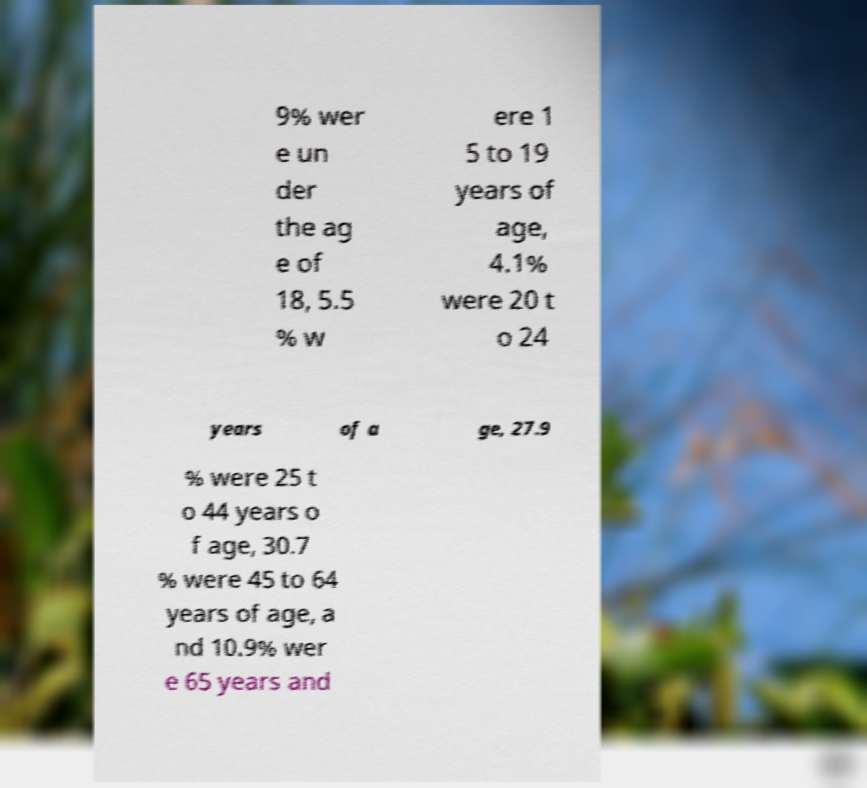Could you assist in decoding the text presented in this image and type it out clearly? 9% wer e un der the ag e of 18, 5.5 % w ere 1 5 to 19 years of age, 4.1% were 20 t o 24 years of a ge, 27.9 % were 25 t o 44 years o f age, 30.7 % were 45 to 64 years of age, a nd 10.9% wer e 65 years and 